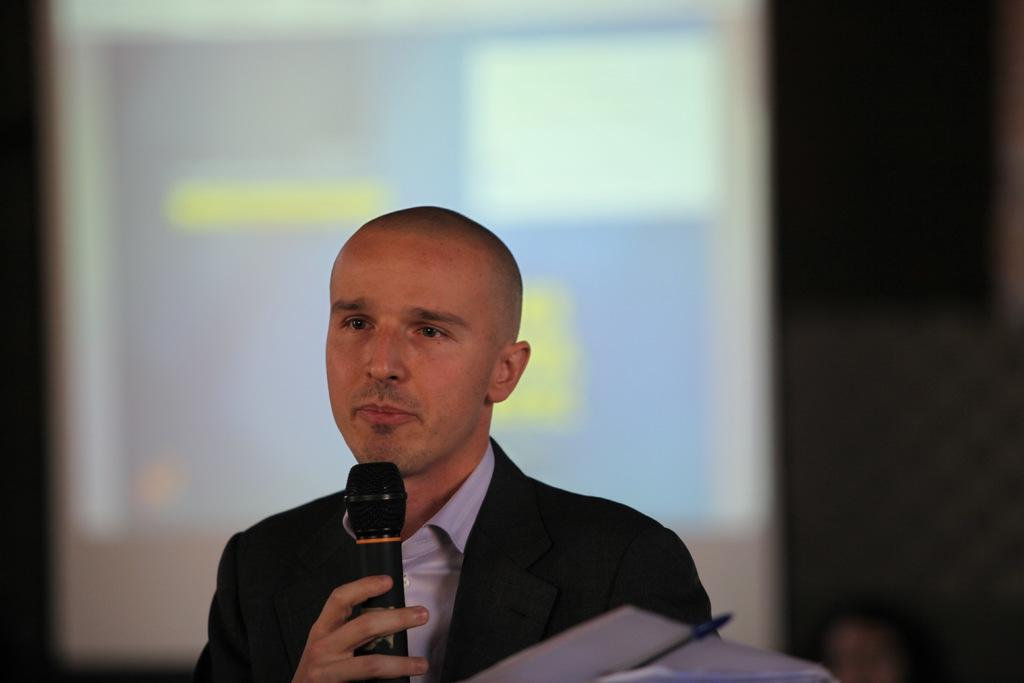What is the main subject of the image? There is a man in the image. What is the man doing in the image? The man is standing in the image. What object is the man holding in his hand? The man is holding a microphone in his hand. What items related to writing can be seen in the image? There are papers with a pen in the image. What is the man wearing in the image? The man is wearing a black coat in the image. Can you see a toothbrush in the image? There is no toothbrush present in the image. 